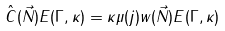<formula> <loc_0><loc_0><loc_500><loc_500>\hat { C } ( \vec { N } ) E ( \Gamma , \kappa ) = \kappa \mu ( j ) w ( \vec { N } ) E ( \Gamma , \kappa )</formula> 